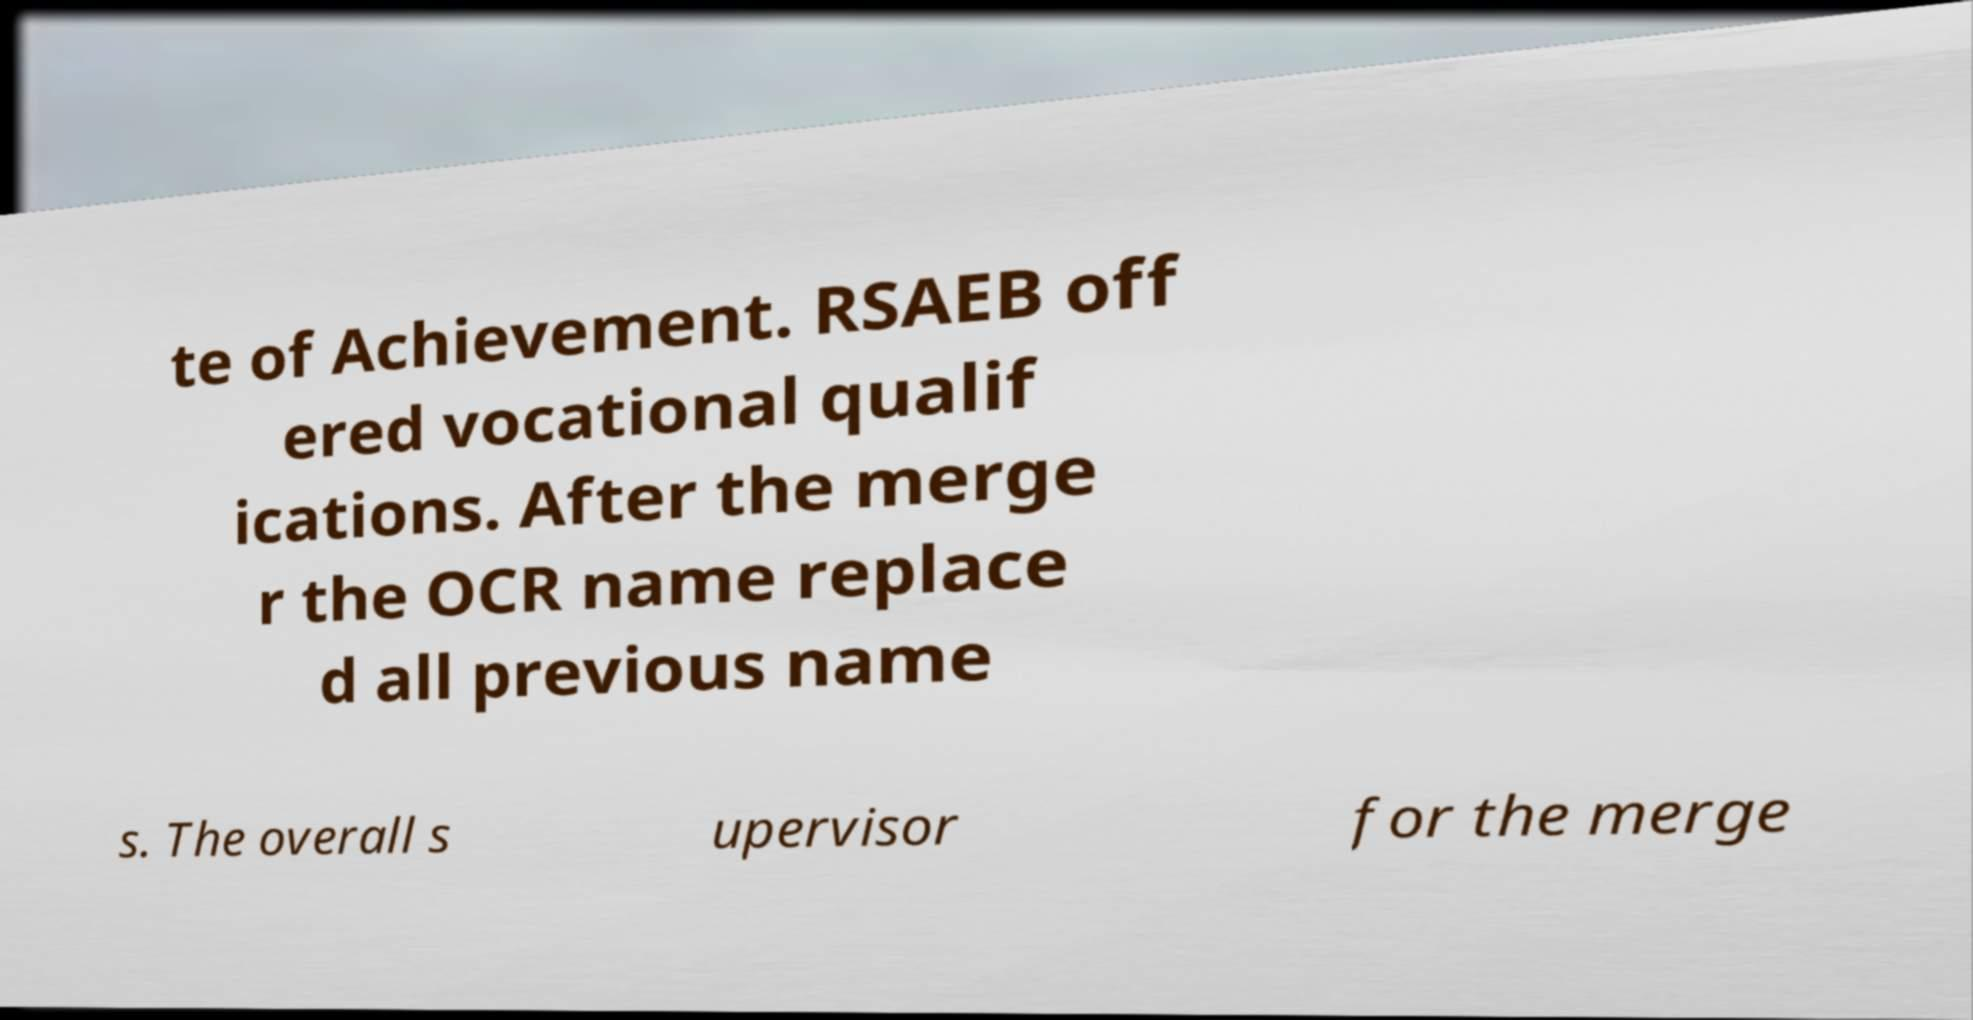Please read and relay the text visible in this image. What does it say? te of Achievement. RSAEB off ered vocational qualif ications. After the merge r the OCR name replace d all previous name s. The overall s upervisor for the merge 